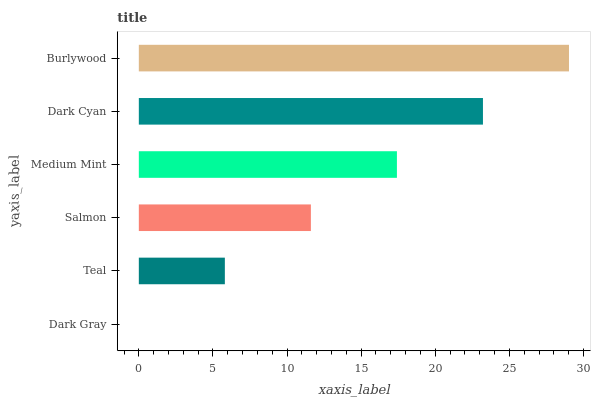Is Dark Gray the minimum?
Answer yes or no. Yes. Is Burlywood the maximum?
Answer yes or no. Yes. Is Teal the minimum?
Answer yes or no. No. Is Teal the maximum?
Answer yes or no. No. Is Teal greater than Dark Gray?
Answer yes or no. Yes. Is Dark Gray less than Teal?
Answer yes or no. Yes. Is Dark Gray greater than Teal?
Answer yes or no. No. Is Teal less than Dark Gray?
Answer yes or no. No. Is Medium Mint the high median?
Answer yes or no. Yes. Is Salmon the low median?
Answer yes or no. Yes. Is Salmon the high median?
Answer yes or no. No. Is Medium Mint the low median?
Answer yes or no. No. 